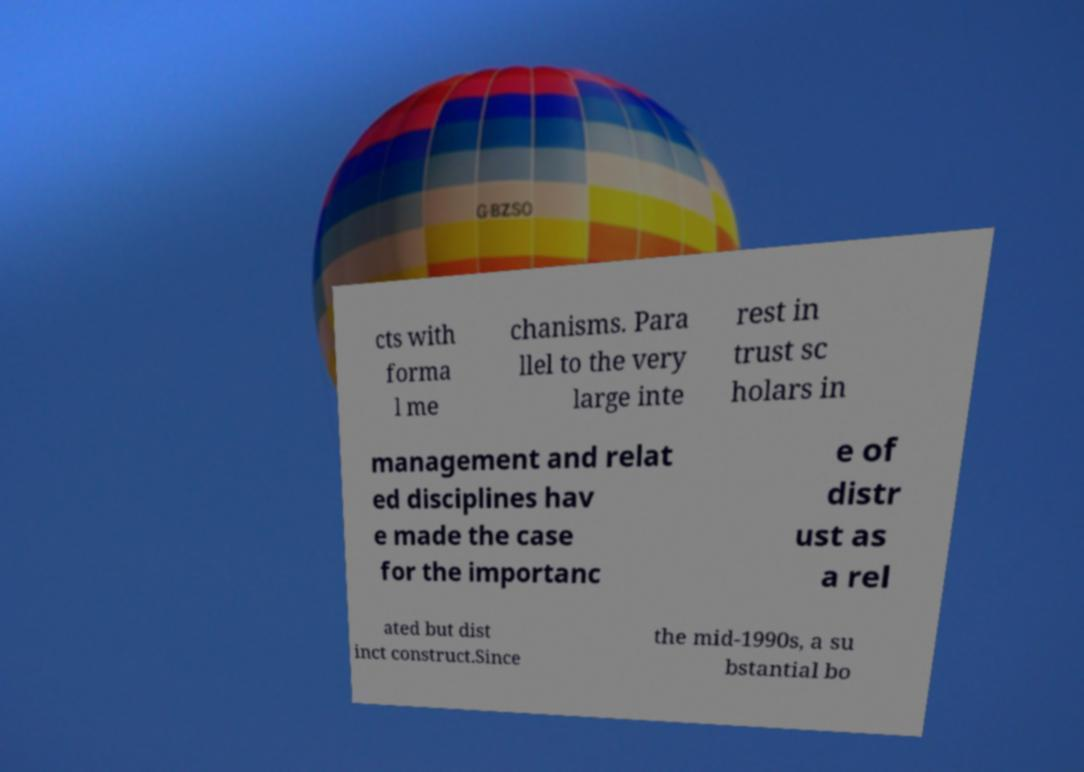Could you assist in decoding the text presented in this image and type it out clearly? cts with forma l me chanisms. Para llel to the very large inte rest in trust sc holars in management and relat ed disciplines hav e made the case for the importanc e of distr ust as a rel ated but dist inct construct.Since the mid-1990s, a su bstantial bo 